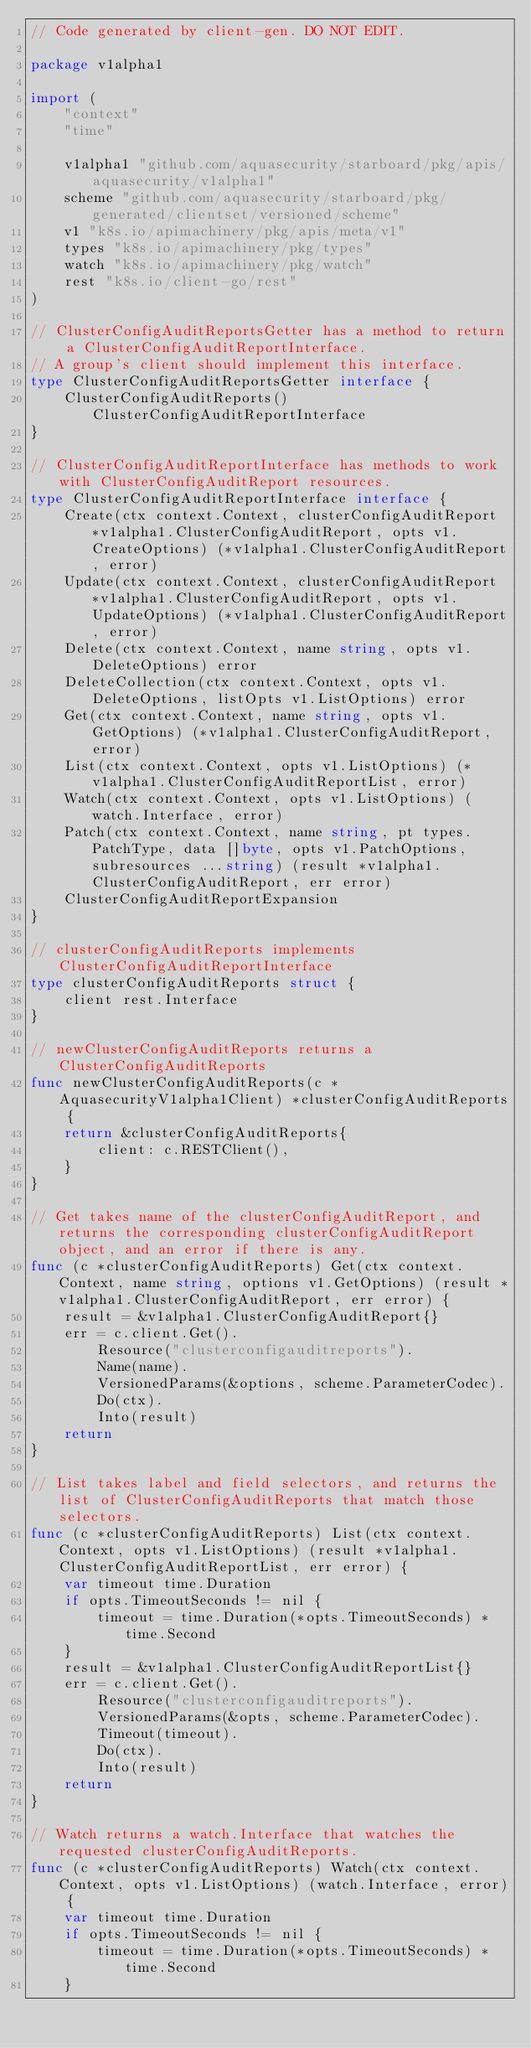Convert code to text. <code><loc_0><loc_0><loc_500><loc_500><_Go_>// Code generated by client-gen. DO NOT EDIT.

package v1alpha1

import (
	"context"
	"time"

	v1alpha1 "github.com/aquasecurity/starboard/pkg/apis/aquasecurity/v1alpha1"
	scheme "github.com/aquasecurity/starboard/pkg/generated/clientset/versioned/scheme"
	v1 "k8s.io/apimachinery/pkg/apis/meta/v1"
	types "k8s.io/apimachinery/pkg/types"
	watch "k8s.io/apimachinery/pkg/watch"
	rest "k8s.io/client-go/rest"
)

// ClusterConfigAuditReportsGetter has a method to return a ClusterConfigAuditReportInterface.
// A group's client should implement this interface.
type ClusterConfigAuditReportsGetter interface {
	ClusterConfigAuditReports() ClusterConfigAuditReportInterface
}

// ClusterConfigAuditReportInterface has methods to work with ClusterConfigAuditReport resources.
type ClusterConfigAuditReportInterface interface {
	Create(ctx context.Context, clusterConfigAuditReport *v1alpha1.ClusterConfigAuditReport, opts v1.CreateOptions) (*v1alpha1.ClusterConfigAuditReport, error)
	Update(ctx context.Context, clusterConfigAuditReport *v1alpha1.ClusterConfigAuditReport, opts v1.UpdateOptions) (*v1alpha1.ClusterConfigAuditReport, error)
	Delete(ctx context.Context, name string, opts v1.DeleteOptions) error
	DeleteCollection(ctx context.Context, opts v1.DeleteOptions, listOpts v1.ListOptions) error
	Get(ctx context.Context, name string, opts v1.GetOptions) (*v1alpha1.ClusterConfigAuditReport, error)
	List(ctx context.Context, opts v1.ListOptions) (*v1alpha1.ClusterConfigAuditReportList, error)
	Watch(ctx context.Context, opts v1.ListOptions) (watch.Interface, error)
	Patch(ctx context.Context, name string, pt types.PatchType, data []byte, opts v1.PatchOptions, subresources ...string) (result *v1alpha1.ClusterConfigAuditReport, err error)
	ClusterConfigAuditReportExpansion
}

// clusterConfigAuditReports implements ClusterConfigAuditReportInterface
type clusterConfigAuditReports struct {
	client rest.Interface
}

// newClusterConfigAuditReports returns a ClusterConfigAuditReports
func newClusterConfigAuditReports(c *AquasecurityV1alpha1Client) *clusterConfigAuditReports {
	return &clusterConfigAuditReports{
		client: c.RESTClient(),
	}
}

// Get takes name of the clusterConfigAuditReport, and returns the corresponding clusterConfigAuditReport object, and an error if there is any.
func (c *clusterConfigAuditReports) Get(ctx context.Context, name string, options v1.GetOptions) (result *v1alpha1.ClusterConfigAuditReport, err error) {
	result = &v1alpha1.ClusterConfigAuditReport{}
	err = c.client.Get().
		Resource("clusterconfigauditreports").
		Name(name).
		VersionedParams(&options, scheme.ParameterCodec).
		Do(ctx).
		Into(result)
	return
}

// List takes label and field selectors, and returns the list of ClusterConfigAuditReports that match those selectors.
func (c *clusterConfigAuditReports) List(ctx context.Context, opts v1.ListOptions) (result *v1alpha1.ClusterConfigAuditReportList, err error) {
	var timeout time.Duration
	if opts.TimeoutSeconds != nil {
		timeout = time.Duration(*opts.TimeoutSeconds) * time.Second
	}
	result = &v1alpha1.ClusterConfigAuditReportList{}
	err = c.client.Get().
		Resource("clusterconfigauditreports").
		VersionedParams(&opts, scheme.ParameterCodec).
		Timeout(timeout).
		Do(ctx).
		Into(result)
	return
}

// Watch returns a watch.Interface that watches the requested clusterConfigAuditReports.
func (c *clusterConfigAuditReports) Watch(ctx context.Context, opts v1.ListOptions) (watch.Interface, error) {
	var timeout time.Duration
	if opts.TimeoutSeconds != nil {
		timeout = time.Duration(*opts.TimeoutSeconds) * time.Second
	}</code> 